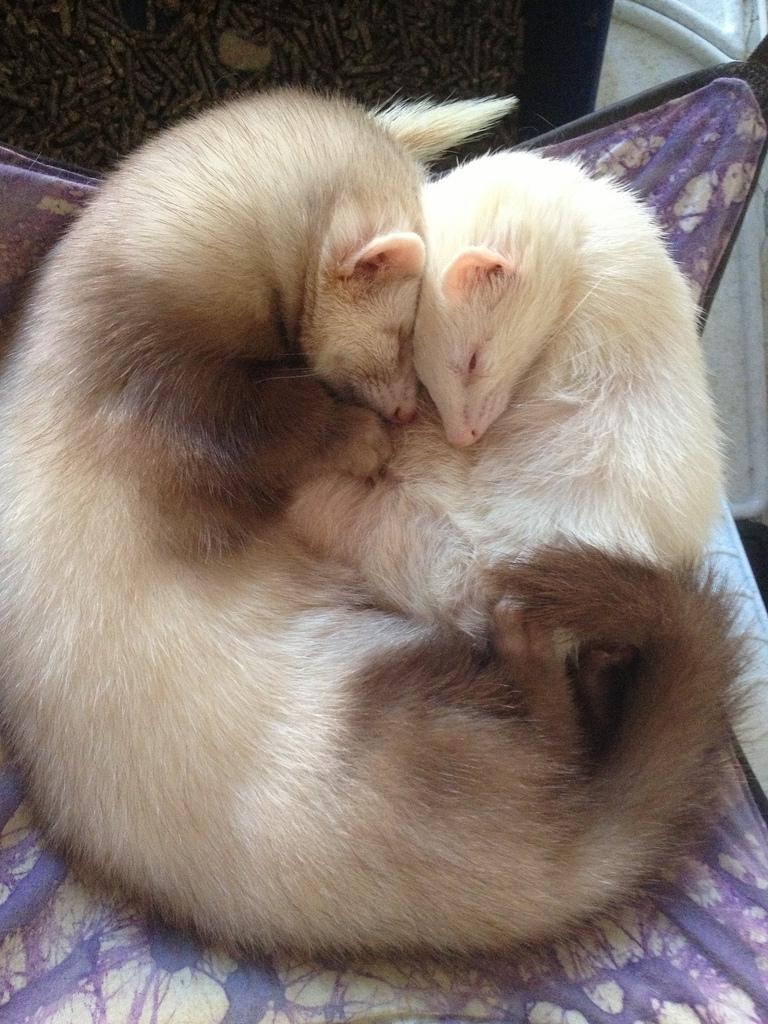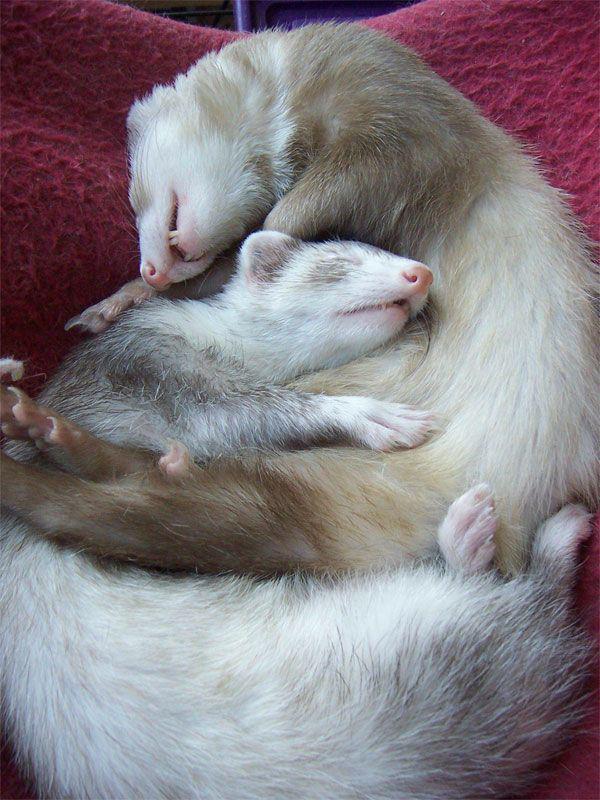The first image is the image on the left, the second image is the image on the right. For the images shown, is this caption "There are exactly four ferrets." true? Answer yes or no. Yes. 